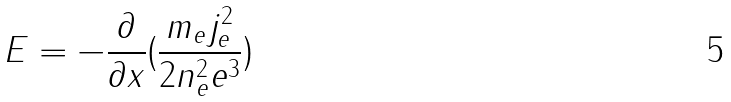Convert formula to latex. <formula><loc_0><loc_0><loc_500><loc_500>E = - \frac { \partial } { \partial x } ( \frac { m _ { e } j _ { e } ^ { 2 } } { 2 n _ { e } ^ { 2 } e ^ { 3 } } )</formula> 